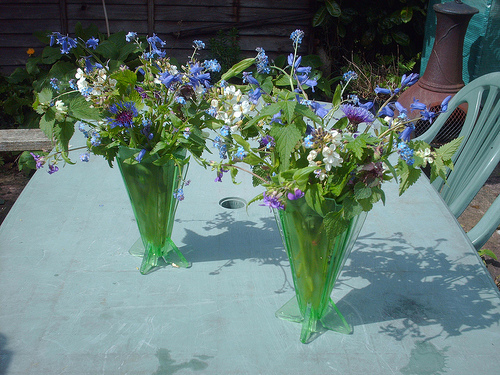What types of plants can be identified in the vases? The vases appear to be brimming with various species, including clusters of blue forget-me-nots and possibly white blossoms of sweet alyssum, all complemented by rich green foliage that indicates a well-tended selection of garden flowers. Are there any observable gardening tools or equipment? No distinct gardening tools or equipment are immediately visible in this image; it seems to focus more on the leisure aspect of a garden rather than its maintenance. 